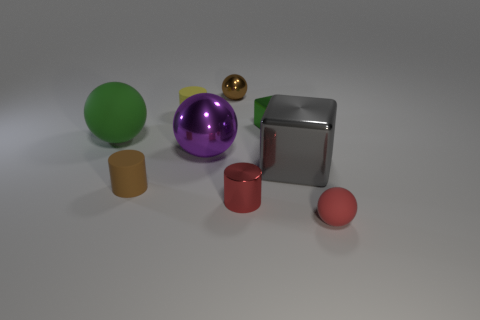What number of objects have the same color as the small shiny ball?
Ensure brevity in your answer.  1. There is a ball that is both in front of the large rubber thing and behind the red rubber ball; what is its color?
Offer a very short reply. Purple. There is a purple metallic thing; are there any gray metallic blocks to the left of it?
Your answer should be compact. No. What number of tiny brown rubber cylinders are in front of the green thing left of the yellow matte thing?
Make the answer very short. 1. There is a brown object that is the same material as the purple sphere; what size is it?
Ensure brevity in your answer.  Small. The purple ball has what size?
Offer a very short reply. Large. Does the large purple thing have the same material as the green sphere?
Offer a terse response. No. What number of balls are brown rubber objects or tiny yellow matte objects?
Give a very brief answer. 0. There is a rubber thing that is to the right of the tiny ball to the left of the tiny green cube; what color is it?
Offer a terse response. Red. There is a shiny cube that is the same color as the large matte sphere; what size is it?
Give a very brief answer. Small. 